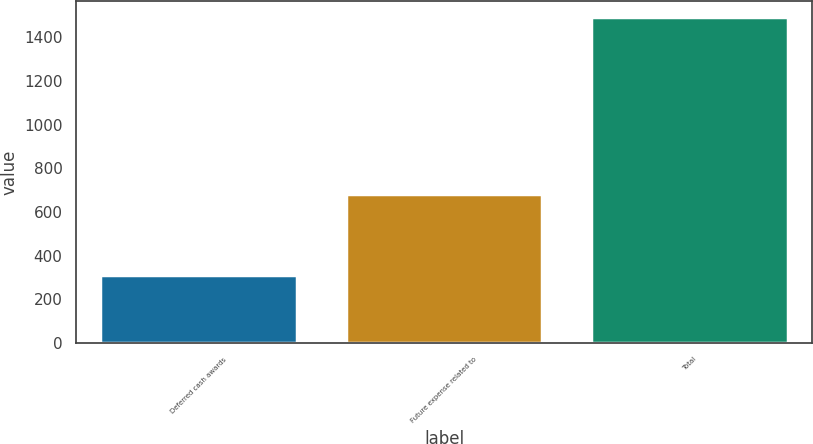Convert chart to OTSL. <chart><loc_0><loc_0><loc_500><loc_500><bar_chart><fcel>Deferred cash awards<fcel>Future expense related to<fcel>Total<nl><fcel>310<fcel>682<fcel>1492<nl></chart> 